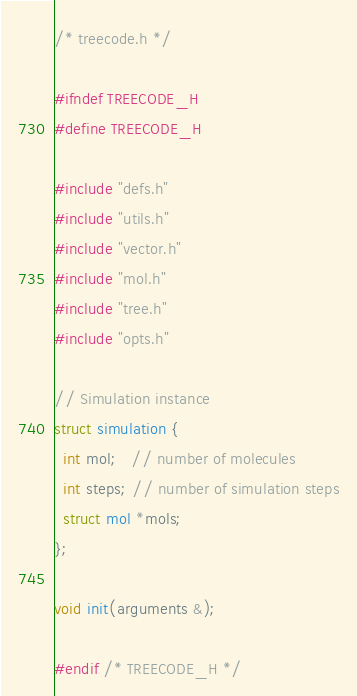<code> <loc_0><loc_0><loc_500><loc_500><_C_>/* treecode.h */

#ifndef TREECODE_H
#define TREECODE_H

#include "defs.h"
#include "utils.h"
#include "vector.h"
#include "mol.h"
#include "tree.h"
#include "opts.h"

// Simulation instance
struct simulation {
  int mol;   // number of molecules
  int steps; // number of simulation steps
  struct mol *mols;
};

void init(arguments &);

#endif /* TREECODE_H */
</code> 